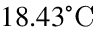<formula> <loc_0><loc_0><loc_500><loc_500>1 8 . 4 3 ^ { \circ } C</formula> 